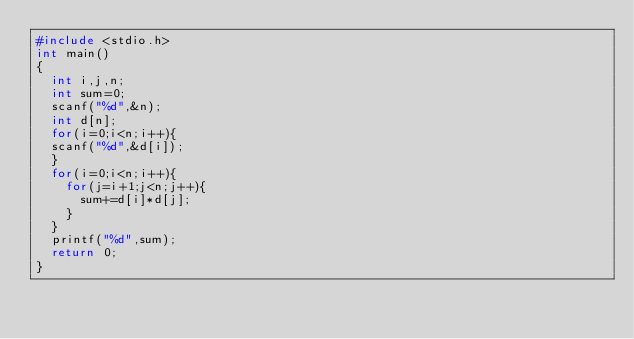<code> <loc_0><loc_0><loc_500><loc_500><_C_>#include <stdio.h>
int main()
{
  int i,j,n;
  int sum=0;
  scanf("%d",&n);
  int d[n];
  for(i=0;i<n;i++){
  scanf("%d",&d[i]);
  }
  for(i=0;i<n;i++){
    for(j=i+1;j<n;j++){
      sum+=d[i]*d[j];
    }
  }
  printf("%d",sum);
  return 0;
}</code> 